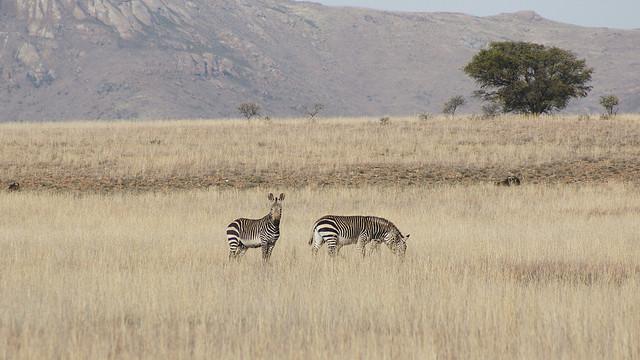How many animals are partially in the photograph?
Short answer required. 2. Are these sheep?
Concise answer only. No. Is there water in the picture?
Write a very short answer. No. How many animal are there?
Quick response, please. 2. Is the zebra on the left looking at the camera?
Answer briefly. Yes. Does the zebra look lonely?
Give a very brief answer. No. How many species are in this picture?
Give a very brief answer. 1. What is in the background?
Quick response, please. Mountains. How many zebra?
Concise answer only. 2. 